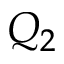<formula> <loc_0><loc_0><loc_500><loc_500>Q _ { 2 }</formula> 